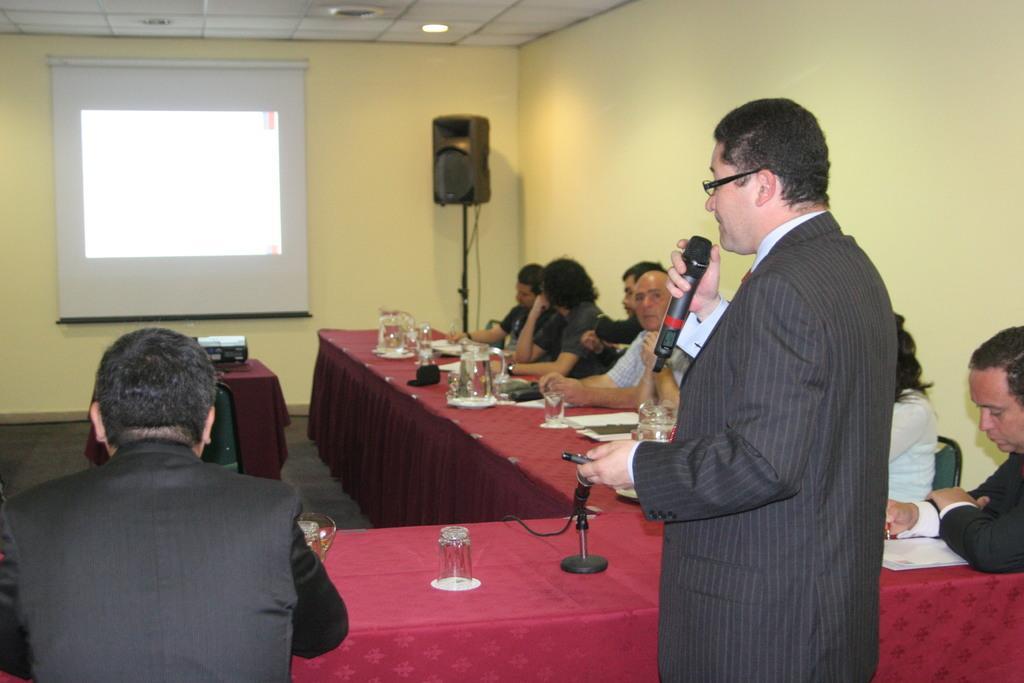Please provide a concise description of this image. In this image there is a person standing and speaking in a mic holding in his hand, in front of the person there are a few people seated in chairs, in front of them on the table there are some objects, in front of them there is a speaker and there is a projector on a table with a chair in front of it, in the background of the image there is a projector with screen on the wall. 